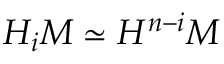<formula> <loc_0><loc_0><loc_500><loc_500>H _ { i } M \simeq H ^ { n - i } M</formula> 